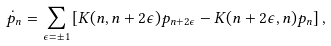Convert formula to latex. <formula><loc_0><loc_0><loc_500><loc_500>\dot { p } _ { n } = \sum _ { \epsilon = \pm 1 } \left [ K ( n , n + 2 \epsilon ) p _ { n + 2 \epsilon } - K ( n + 2 \epsilon , n ) p _ { n } \right ] ,</formula> 